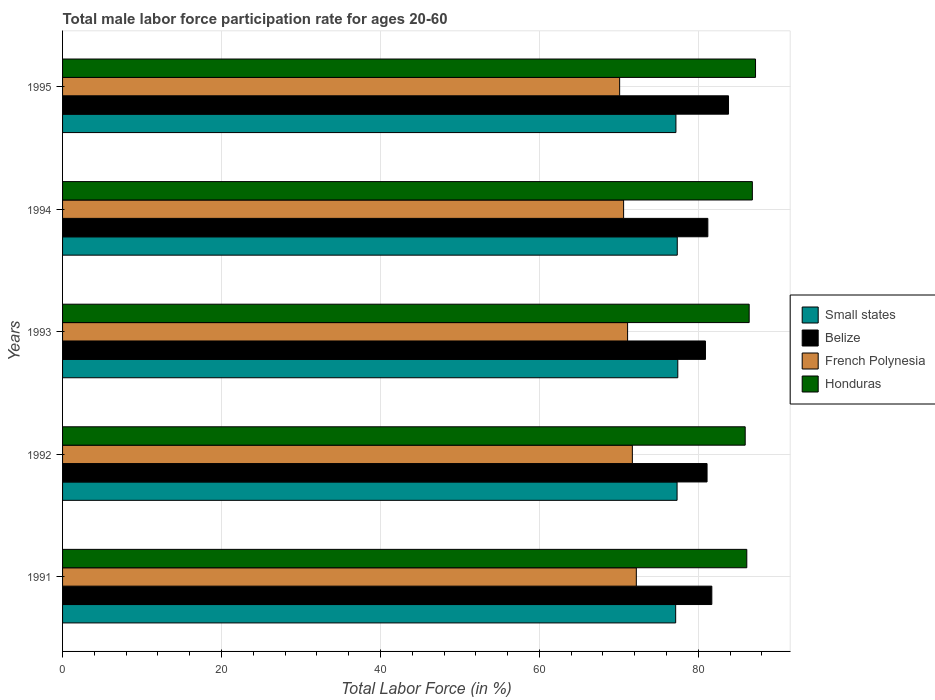How many different coloured bars are there?
Provide a succinct answer. 4. How many bars are there on the 3rd tick from the top?
Provide a succinct answer. 4. How many bars are there on the 4th tick from the bottom?
Provide a short and direct response. 4. In how many cases, is the number of bars for a given year not equal to the number of legend labels?
Make the answer very short. 0. What is the male labor force participation rate in Honduras in 1991?
Your response must be concise. 86.1. Across all years, what is the maximum male labor force participation rate in French Polynesia?
Offer a very short reply. 72.2. Across all years, what is the minimum male labor force participation rate in French Polynesia?
Ensure brevity in your answer.  70.1. In which year was the male labor force participation rate in Belize minimum?
Your response must be concise. 1993. What is the total male labor force participation rate in Small states in the graph?
Give a very brief answer. 386.43. What is the difference between the male labor force participation rate in Belize in 1992 and that in 1993?
Provide a succinct answer. 0.2. What is the difference between the male labor force participation rate in French Polynesia in 1992 and the male labor force participation rate in Belize in 1995?
Your answer should be very brief. -12.1. What is the average male labor force participation rate in Small states per year?
Your answer should be compact. 77.29. In the year 1995, what is the difference between the male labor force participation rate in French Polynesia and male labor force participation rate in Honduras?
Provide a short and direct response. -17.1. What is the ratio of the male labor force participation rate in Small states in 1991 to that in 1994?
Your answer should be very brief. 1. Is the male labor force participation rate in Honduras in 1993 less than that in 1994?
Your answer should be very brief. Yes. Is the difference between the male labor force participation rate in French Polynesia in 1994 and 1995 greater than the difference between the male labor force participation rate in Honduras in 1994 and 1995?
Offer a very short reply. Yes. What is the difference between the highest and the second highest male labor force participation rate in Small states?
Offer a very short reply. 0.07. What is the difference between the highest and the lowest male labor force participation rate in French Polynesia?
Offer a very short reply. 2.1. In how many years, is the male labor force participation rate in Belize greater than the average male labor force participation rate in Belize taken over all years?
Offer a very short reply. 1. Is it the case that in every year, the sum of the male labor force participation rate in Honduras and male labor force participation rate in Small states is greater than the sum of male labor force participation rate in French Polynesia and male labor force participation rate in Belize?
Offer a very short reply. No. What does the 1st bar from the top in 1995 represents?
Ensure brevity in your answer.  Honduras. What does the 1st bar from the bottom in 1991 represents?
Offer a terse response. Small states. Is it the case that in every year, the sum of the male labor force participation rate in Honduras and male labor force participation rate in French Polynesia is greater than the male labor force participation rate in Belize?
Your answer should be very brief. Yes. How many bars are there?
Offer a terse response. 20. Are all the bars in the graph horizontal?
Ensure brevity in your answer.  Yes. How many years are there in the graph?
Your response must be concise. 5. What is the difference between two consecutive major ticks on the X-axis?
Your response must be concise. 20. How are the legend labels stacked?
Your answer should be compact. Vertical. What is the title of the graph?
Make the answer very short. Total male labor force participation rate for ages 20-60. Does "Syrian Arab Republic" appear as one of the legend labels in the graph?
Ensure brevity in your answer.  No. What is the label or title of the X-axis?
Keep it short and to the point. Total Labor Force (in %). What is the label or title of the Y-axis?
Provide a succinct answer. Years. What is the Total Labor Force (in %) in Small states in 1991?
Give a very brief answer. 77.15. What is the Total Labor Force (in %) in Belize in 1991?
Offer a very short reply. 81.7. What is the Total Labor Force (in %) of French Polynesia in 1991?
Make the answer very short. 72.2. What is the Total Labor Force (in %) in Honduras in 1991?
Offer a terse response. 86.1. What is the Total Labor Force (in %) of Small states in 1992?
Your response must be concise. 77.33. What is the Total Labor Force (in %) in Belize in 1992?
Your answer should be compact. 81.1. What is the Total Labor Force (in %) in French Polynesia in 1992?
Provide a short and direct response. 71.7. What is the Total Labor Force (in %) of Honduras in 1992?
Offer a very short reply. 85.9. What is the Total Labor Force (in %) of Small states in 1993?
Offer a very short reply. 77.42. What is the Total Labor Force (in %) in Belize in 1993?
Provide a short and direct response. 80.9. What is the Total Labor Force (in %) in French Polynesia in 1993?
Give a very brief answer. 71.1. What is the Total Labor Force (in %) of Honduras in 1993?
Offer a very short reply. 86.4. What is the Total Labor Force (in %) of Small states in 1994?
Offer a terse response. 77.35. What is the Total Labor Force (in %) of Belize in 1994?
Give a very brief answer. 81.2. What is the Total Labor Force (in %) in French Polynesia in 1994?
Make the answer very short. 70.6. What is the Total Labor Force (in %) in Honduras in 1994?
Your answer should be very brief. 86.8. What is the Total Labor Force (in %) of Small states in 1995?
Ensure brevity in your answer.  77.18. What is the Total Labor Force (in %) of Belize in 1995?
Your response must be concise. 83.8. What is the Total Labor Force (in %) of French Polynesia in 1995?
Your answer should be very brief. 70.1. What is the Total Labor Force (in %) of Honduras in 1995?
Your answer should be very brief. 87.2. Across all years, what is the maximum Total Labor Force (in %) of Small states?
Your answer should be compact. 77.42. Across all years, what is the maximum Total Labor Force (in %) of Belize?
Offer a terse response. 83.8. Across all years, what is the maximum Total Labor Force (in %) of French Polynesia?
Your response must be concise. 72.2. Across all years, what is the maximum Total Labor Force (in %) of Honduras?
Offer a terse response. 87.2. Across all years, what is the minimum Total Labor Force (in %) of Small states?
Offer a terse response. 77.15. Across all years, what is the minimum Total Labor Force (in %) in Belize?
Your response must be concise. 80.9. Across all years, what is the minimum Total Labor Force (in %) of French Polynesia?
Your answer should be very brief. 70.1. Across all years, what is the minimum Total Labor Force (in %) in Honduras?
Keep it short and to the point. 85.9. What is the total Total Labor Force (in %) in Small states in the graph?
Offer a very short reply. 386.43. What is the total Total Labor Force (in %) of Belize in the graph?
Ensure brevity in your answer.  408.7. What is the total Total Labor Force (in %) in French Polynesia in the graph?
Your answer should be compact. 355.7. What is the total Total Labor Force (in %) of Honduras in the graph?
Offer a very short reply. 432.4. What is the difference between the Total Labor Force (in %) of Small states in 1991 and that in 1992?
Make the answer very short. -0.18. What is the difference between the Total Labor Force (in %) of French Polynesia in 1991 and that in 1992?
Give a very brief answer. 0.5. What is the difference between the Total Labor Force (in %) in Small states in 1991 and that in 1993?
Give a very brief answer. -0.27. What is the difference between the Total Labor Force (in %) of Belize in 1991 and that in 1993?
Offer a terse response. 0.8. What is the difference between the Total Labor Force (in %) in Small states in 1991 and that in 1994?
Offer a terse response. -0.2. What is the difference between the Total Labor Force (in %) of Belize in 1991 and that in 1994?
Offer a very short reply. 0.5. What is the difference between the Total Labor Force (in %) of Honduras in 1991 and that in 1994?
Offer a terse response. -0.7. What is the difference between the Total Labor Force (in %) in Small states in 1991 and that in 1995?
Give a very brief answer. -0.03. What is the difference between the Total Labor Force (in %) in Small states in 1992 and that in 1993?
Your answer should be compact. -0.09. What is the difference between the Total Labor Force (in %) of Belize in 1992 and that in 1993?
Offer a very short reply. 0.2. What is the difference between the Total Labor Force (in %) in French Polynesia in 1992 and that in 1993?
Keep it short and to the point. 0.6. What is the difference between the Total Labor Force (in %) of Small states in 1992 and that in 1994?
Keep it short and to the point. -0.02. What is the difference between the Total Labor Force (in %) in French Polynesia in 1992 and that in 1994?
Keep it short and to the point. 1.1. What is the difference between the Total Labor Force (in %) of Honduras in 1992 and that in 1994?
Ensure brevity in your answer.  -0.9. What is the difference between the Total Labor Force (in %) of Small states in 1992 and that in 1995?
Your answer should be very brief. 0.15. What is the difference between the Total Labor Force (in %) of Small states in 1993 and that in 1994?
Keep it short and to the point. 0.07. What is the difference between the Total Labor Force (in %) of Honduras in 1993 and that in 1994?
Ensure brevity in your answer.  -0.4. What is the difference between the Total Labor Force (in %) in Small states in 1993 and that in 1995?
Keep it short and to the point. 0.24. What is the difference between the Total Labor Force (in %) of Belize in 1993 and that in 1995?
Offer a very short reply. -2.9. What is the difference between the Total Labor Force (in %) in Small states in 1994 and that in 1995?
Provide a succinct answer. 0.17. What is the difference between the Total Labor Force (in %) in French Polynesia in 1994 and that in 1995?
Make the answer very short. 0.5. What is the difference between the Total Labor Force (in %) of Small states in 1991 and the Total Labor Force (in %) of Belize in 1992?
Provide a succinct answer. -3.95. What is the difference between the Total Labor Force (in %) in Small states in 1991 and the Total Labor Force (in %) in French Polynesia in 1992?
Ensure brevity in your answer.  5.45. What is the difference between the Total Labor Force (in %) in Small states in 1991 and the Total Labor Force (in %) in Honduras in 1992?
Your answer should be compact. -8.75. What is the difference between the Total Labor Force (in %) of Belize in 1991 and the Total Labor Force (in %) of French Polynesia in 1992?
Ensure brevity in your answer.  10. What is the difference between the Total Labor Force (in %) in Belize in 1991 and the Total Labor Force (in %) in Honduras in 1992?
Offer a terse response. -4.2. What is the difference between the Total Labor Force (in %) of French Polynesia in 1991 and the Total Labor Force (in %) of Honduras in 1992?
Ensure brevity in your answer.  -13.7. What is the difference between the Total Labor Force (in %) of Small states in 1991 and the Total Labor Force (in %) of Belize in 1993?
Your answer should be compact. -3.75. What is the difference between the Total Labor Force (in %) of Small states in 1991 and the Total Labor Force (in %) of French Polynesia in 1993?
Your response must be concise. 6.05. What is the difference between the Total Labor Force (in %) in Small states in 1991 and the Total Labor Force (in %) in Honduras in 1993?
Provide a succinct answer. -9.25. What is the difference between the Total Labor Force (in %) of Belize in 1991 and the Total Labor Force (in %) of Honduras in 1993?
Give a very brief answer. -4.7. What is the difference between the Total Labor Force (in %) of French Polynesia in 1991 and the Total Labor Force (in %) of Honduras in 1993?
Offer a terse response. -14.2. What is the difference between the Total Labor Force (in %) of Small states in 1991 and the Total Labor Force (in %) of Belize in 1994?
Your answer should be compact. -4.05. What is the difference between the Total Labor Force (in %) in Small states in 1991 and the Total Labor Force (in %) in French Polynesia in 1994?
Your answer should be very brief. 6.55. What is the difference between the Total Labor Force (in %) in Small states in 1991 and the Total Labor Force (in %) in Honduras in 1994?
Your answer should be compact. -9.65. What is the difference between the Total Labor Force (in %) of Belize in 1991 and the Total Labor Force (in %) of French Polynesia in 1994?
Your response must be concise. 11.1. What is the difference between the Total Labor Force (in %) of French Polynesia in 1991 and the Total Labor Force (in %) of Honduras in 1994?
Your answer should be very brief. -14.6. What is the difference between the Total Labor Force (in %) of Small states in 1991 and the Total Labor Force (in %) of Belize in 1995?
Offer a terse response. -6.65. What is the difference between the Total Labor Force (in %) of Small states in 1991 and the Total Labor Force (in %) of French Polynesia in 1995?
Your answer should be compact. 7.05. What is the difference between the Total Labor Force (in %) of Small states in 1991 and the Total Labor Force (in %) of Honduras in 1995?
Your answer should be compact. -10.05. What is the difference between the Total Labor Force (in %) in Belize in 1991 and the Total Labor Force (in %) in French Polynesia in 1995?
Offer a terse response. 11.6. What is the difference between the Total Labor Force (in %) of Belize in 1991 and the Total Labor Force (in %) of Honduras in 1995?
Provide a succinct answer. -5.5. What is the difference between the Total Labor Force (in %) in French Polynesia in 1991 and the Total Labor Force (in %) in Honduras in 1995?
Give a very brief answer. -15. What is the difference between the Total Labor Force (in %) in Small states in 1992 and the Total Labor Force (in %) in Belize in 1993?
Provide a succinct answer. -3.57. What is the difference between the Total Labor Force (in %) in Small states in 1992 and the Total Labor Force (in %) in French Polynesia in 1993?
Provide a short and direct response. 6.23. What is the difference between the Total Labor Force (in %) in Small states in 1992 and the Total Labor Force (in %) in Honduras in 1993?
Your answer should be very brief. -9.07. What is the difference between the Total Labor Force (in %) in Belize in 1992 and the Total Labor Force (in %) in French Polynesia in 1993?
Give a very brief answer. 10. What is the difference between the Total Labor Force (in %) of French Polynesia in 1992 and the Total Labor Force (in %) of Honduras in 1993?
Keep it short and to the point. -14.7. What is the difference between the Total Labor Force (in %) in Small states in 1992 and the Total Labor Force (in %) in Belize in 1994?
Offer a very short reply. -3.87. What is the difference between the Total Labor Force (in %) in Small states in 1992 and the Total Labor Force (in %) in French Polynesia in 1994?
Your response must be concise. 6.73. What is the difference between the Total Labor Force (in %) of Small states in 1992 and the Total Labor Force (in %) of Honduras in 1994?
Make the answer very short. -9.47. What is the difference between the Total Labor Force (in %) of French Polynesia in 1992 and the Total Labor Force (in %) of Honduras in 1994?
Ensure brevity in your answer.  -15.1. What is the difference between the Total Labor Force (in %) of Small states in 1992 and the Total Labor Force (in %) of Belize in 1995?
Offer a very short reply. -6.47. What is the difference between the Total Labor Force (in %) of Small states in 1992 and the Total Labor Force (in %) of French Polynesia in 1995?
Provide a short and direct response. 7.23. What is the difference between the Total Labor Force (in %) of Small states in 1992 and the Total Labor Force (in %) of Honduras in 1995?
Your answer should be very brief. -9.87. What is the difference between the Total Labor Force (in %) of Belize in 1992 and the Total Labor Force (in %) of French Polynesia in 1995?
Offer a terse response. 11. What is the difference between the Total Labor Force (in %) in French Polynesia in 1992 and the Total Labor Force (in %) in Honduras in 1995?
Give a very brief answer. -15.5. What is the difference between the Total Labor Force (in %) in Small states in 1993 and the Total Labor Force (in %) in Belize in 1994?
Offer a very short reply. -3.78. What is the difference between the Total Labor Force (in %) of Small states in 1993 and the Total Labor Force (in %) of French Polynesia in 1994?
Make the answer very short. 6.82. What is the difference between the Total Labor Force (in %) of Small states in 1993 and the Total Labor Force (in %) of Honduras in 1994?
Provide a short and direct response. -9.38. What is the difference between the Total Labor Force (in %) of French Polynesia in 1993 and the Total Labor Force (in %) of Honduras in 1994?
Make the answer very short. -15.7. What is the difference between the Total Labor Force (in %) in Small states in 1993 and the Total Labor Force (in %) in Belize in 1995?
Offer a terse response. -6.38. What is the difference between the Total Labor Force (in %) of Small states in 1993 and the Total Labor Force (in %) of French Polynesia in 1995?
Offer a very short reply. 7.32. What is the difference between the Total Labor Force (in %) in Small states in 1993 and the Total Labor Force (in %) in Honduras in 1995?
Ensure brevity in your answer.  -9.78. What is the difference between the Total Labor Force (in %) in Belize in 1993 and the Total Labor Force (in %) in French Polynesia in 1995?
Your answer should be very brief. 10.8. What is the difference between the Total Labor Force (in %) of French Polynesia in 1993 and the Total Labor Force (in %) of Honduras in 1995?
Keep it short and to the point. -16.1. What is the difference between the Total Labor Force (in %) of Small states in 1994 and the Total Labor Force (in %) of Belize in 1995?
Give a very brief answer. -6.45. What is the difference between the Total Labor Force (in %) of Small states in 1994 and the Total Labor Force (in %) of French Polynesia in 1995?
Keep it short and to the point. 7.25. What is the difference between the Total Labor Force (in %) in Small states in 1994 and the Total Labor Force (in %) in Honduras in 1995?
Offer a very short reply. -9.85. What is the difference between the Total Labor Force (in %) in Belize in 1994 and the Total Labor Force (in %) in Honduras in 1995?
Offer a very short reply. -6. What is the difference between the Total Labor Force (in %) of French Polynesia in 1994 and the Total Labor Force (in %) of Honduras in 1995?
Give a very brief answer. -16.6. What is the average Total Labor Force (in %) in Small states per year?
Provide a short and direct response. 77.29. What is the average Total Labor Force (in %) of Belize per year?
Offer a terse response. 81.74. What is the average Total Labor Force (in %) of French Polynesia per year?
Offer a very short reply. 71.14. What is the average Total Labor Force (in %) in Honduras per year?
Your answer should be very brief. 86.48. In the year 1991, what is the difference between the Total Labor Force (in %) in Small states and Total Labor Force (in %) in Belize?
Provide a succinct answer. -4.55. In the year 1991, what is the difference between the Total Labor Force (in %) in Small states and Total Labor Force (in %) in French Polynesia?
Keep it short and to the point. 4.95. In the year 1991, what is the difference between the Total Labor Force (in %) in Small states and Total Labor Force (in %) in Honduras?
Provide a succinct answer. -8.95. In the year 1991, what is the difference between the Total Labor Force (in %) of Belize and Total Labor Force (in %) of French Polynesia?
Offer a very short reply. 9.5. In the year 1991, what is the difference between the Total Labor Force (in %) in Belize and Total Labor Force (in %) in Honduras?
Offer a very short reply. -4.4. In the year 1991, what is the difference between the Total Labor Force (in %) of French Polynesia and Total Labor Force (in %) of Honduras?
Give a very brief answer. -13.9. In the year 1992, what is the difference between the Total Labor Force (in %) in Small states and Total Labor Force (in %) in Belize?
Provide a short and direct response. -3.77. In the year 1992, what is the difference between the Total Labor Force (in %) of Small states and Total Labor Force (in %) of French Polynesia?
Ensure brevity in your answer.  5.63. In the year 1992, what is the difference between the Total Labor Force (in %) of Small states and Total Labor Force (in %) of Honduras?
Provide a short and direct response. -8.57. In the year 1992, what is the difference between the Total Labor Force (in %) in Belize and Total Labor Force (in %) in French Polynesia?
Your answer should be compact. 9.4. In the year 1992, what is the difference between the Total Labor Force (in %) in French Polynesia and Total Labor Force (in %) in Honduras?
Your answer should be very brief. -14.2. In the year 1993, what is the difference between the Total Labor Force (in %) of Small states and Total Labor Force (in %) of Belize?
Provide a short and direct response. -3.48. In the year 1993, what is the difference between the Total Labor Force (in %) in Small states and Total Labor Force (in %) in French Polynesia?
Keep it short and to the point. 6.32. In the year 1993, what is the difference between the Total Labor Force (in %) of Small states and Total Labor Force (in %) of Honduras?
Offer a terse response. -8.98. In the year 1993, what is the difference between the Total Labor Force (in %) in Belize and Total Labor Force (in %) in French Polynesia?
Your answer should be very brief. 9.8. In the year 1993, what is the difference between the Total Labor Force (in %) of Belize and Total Labor Force (in %) of Honduras?
Offer a terse response. -5.5. In the year 1993, what is the difference between the Total Labor Force (in %) in French Polynesia and Total Labor Force (in %) in Honduras?
Provide a short and direct response. -15.3. In the year 1994, what is the difference between the Total Labor Force (in %) of Small states and Total Labor Force (in %) of Belize?
Provide a short and direct response. -3.85. In the year 1994, what is the difference between the Total Labor Force (in %) of Small states and Total Labor Force (in %) of French Polynesia?
Your response must be concise. 6.75. In the year 1994, what is the difference between the Total Labor Force (in %) of Small states and Total Labor Force (in %) of Honduras?
Provide a succinct answer. -9.45. In the year 1994, what is the difference between the Total Labor Force (in %) in Belize and Total Labor Force (in %) in French Polynesia?
Your response must be concise. 10.6. In the year 1994, what is the difference between the Total Labor Force (in %) in French Polynesia and Total Labor Force (in %) in Honduras?
Offer a very short reply. -16.2. In the year 1995, what is the difference between the Total Labor Force (in %) of Small states and Total Labor Force (in %) of Belize?
Your answer should be compact. -6.62. In the year 1995, what is the difference between the Total Labor Force (in %) of Small states and Total Labor Force (in %) of French Polynesia?
Give a very brief answer. 7.08. In the year 1995, what is the difference between the Total Labor Force (in %) in Small states and Total Labor Force (in %) in Honduras?
Ensure brevity in your answer.  -10.02. In the year 1995, what is the difference between the Total Labor Force (in %) in Belize and Total Labor Force (in %) in French Polynesia?
Offer a terse response. 13.7. In the year 1995, what is the difference between the Total Labor Force (in %) of Belize and Total Labor Force (in %) of Honduras?
Keep it short and to the point. -3.4. In the year 1995, what is the difference between the Total Labor Force (in %) of French Polynesia and Total Labor Force (in %) of Honduras?
Give a very brief answer. -17.1. What is the ratio of the Total Labor Force (in %) of Small states in 1991 to that in 1992?
Give a very brief answer. 1. What is the ratio of the Total Labor Force (in %) in Belize in 1991 to that in 1992?
Your answer should be compact. 1.01. What is the ratio of the Total Labor Force (in %) in Small states in 1991 to that in 1993?
Keep it short and to the point. 1. What is the ratio of the Total Labor Force (in %) in Belize in 1991 to that in 1993?
Your answer should be compact. 1.01. What is the ratio of the Total Labor Force (in %) of French Polynesia in 1991 to that in 1993?
Keep it short and to the point. 1.02. What is the ratio of the Total Labor Force (in %) in Honduras in 1991 to that in 1993?
Keep it short and to the point. 1. What is the ratio of the Total Labor Force (in %) in Small states in 1991 to that in 1994?
Give a very brief answer. 1. What is the ratio of the Total Labor Force (in %) of Belize in 1991 to that in 1994?
Ensure brevity in your answer.  1.01. What is the ratio of the Total Labor Force (in %) of French Polynesia in 1991 to that in 1994?
Make the answer very short. 1.02. What is the ratio of the Total Labor Force (in %) of Small states in 1991 to that in 1995?
Provide a short and direct response. 1. What is the ratio of the Total Labor Force (in %) of Belize in 1991 to that in 1995?
Ensure brevity in your answer.  0.97. What is the ratio of the Total Labor Force (in %) of Honduras in 1991 to that in 1995?
Give a very brief answer. 0.99. What is the ratio of the Total Labor Force (in %) of French Polynesia in 1992 to that in 1993?
Provide a short and direct response. 1.01. What is the ratio of the Total Labor Force (in %) of Honduras in 1992 to that in 1993?
Keep it short and to the point. 0.99. What is the ratio of the Total Labor Force (in %) in Belize in 1992 to that in 1994?
Provide a short and direct response. 1. What is the ratio of the Total Labor Force (in %) in French Polynesia in 1992 to that in 1994?
Keep it short and to the point. 1.02. What is the ratio of the Total Labor Force (in %) of Honduras in 1992 to that in 1994?
Your answer should be very brief. 0.99. What is the ratio of the Total Labor Force (in %) of Small states in 1992 to that in 1995?
Offer a terse response. 1. What is the ratio of the Total Labor Force (in %) of Belize in 1992 to that in 1995?
Your answer should be compact. 0.97. What is the ratio of the Total Labor Force (in %) of French Polynesia in 1992 to that in 1995?
Your answer should be very brief. 1.02. What is the ratio of the Total Labor Force (in %) in Honduras in 1992 to that in 1995?
Offer a terse response. 0.99. What is the ratio of the Total Labor Force (in %) of Small states in 1993 to that in 1994?
Make the answer very short. 1. What is the ratio of the Total Labor Force (in %) in French Polynesia in 1993 to that in 1994?
Provide a succinct answer. 1.01. What is the ratio of the Total Labor Force (in %) in Belize in 1993 to that in 1995?
Ensure brevity in your answer.  0.97. What is the ratio of the Total Labor Force (in %) of French Polynesia in 1993 to that in 1995?
Keep it short and to the point. 1.01. What is the ratio of the Total Labor Force (in %) of Belize in 1994 to that in 1995?
Your answer should be compact. 0.97. What is the ratio of the Total Labor Force (in %) in French Polynesia in 1994 to that in 1995?
Keep it short and to the point. 1.01. What is the difference between the highest and the second highest Total Labor Force (in %) in Small states?
Provide a short and direct response. 0.07. What is the difference between the highest and the second highest Total Labor Force (in %) of Belize?
Your answer should be compact. 2.1. What is the difference between the highest and the second highest Total Labor Force (in %) in French Polynesia?
Offer a terse response. 0.5. What is the difference between the highest and the second highest Total Labor Force (in %) in Honduras?
Ensure brevity in your answer.  0.4. What is the difference between the highest and the lowest Total Labor Force (in %) in Small states?
Ensure brevity in your answer.  0.27. What is the difference between the highest and the lowest Total Labor Force (in %) of French Polynesia?
Keep it short and to the point. 2.1. 